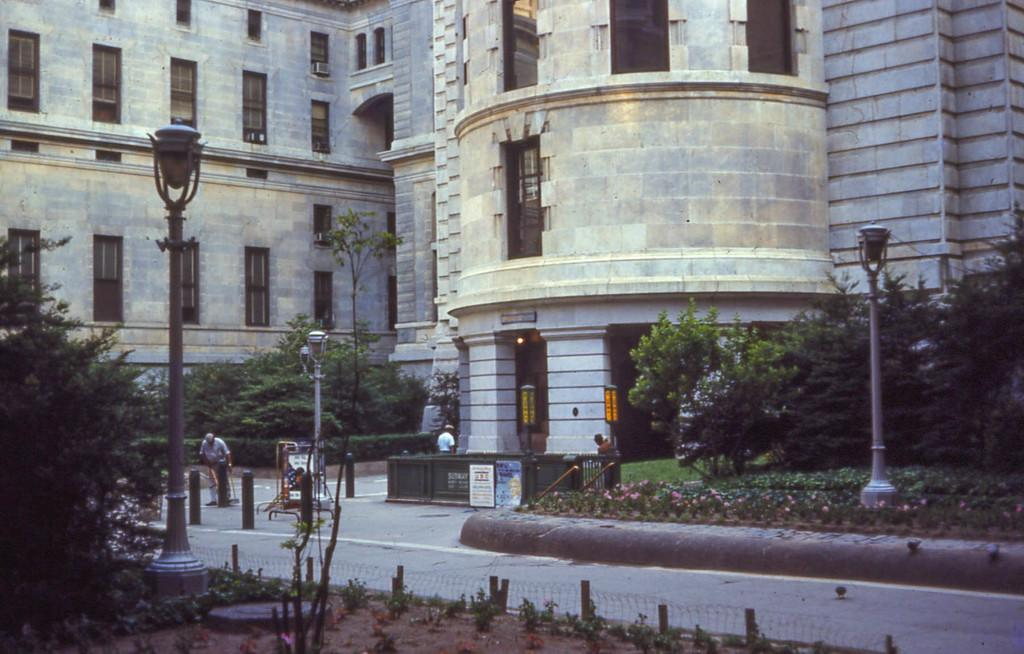What type of vegetation can be seen in the image? There are trees and plants in the image. What is located in the foreground area of the image? There is net fencing and poles in the foreground area of the image. What can be seen in the background of the image? There are people, posters, trees, and a building in the background of the image. Can you tell me how much the muscle costs in the image? There is no mention of a muscle or any cost in the image; it features trees, plants, net fencing, poles, people, posters, and a building. 